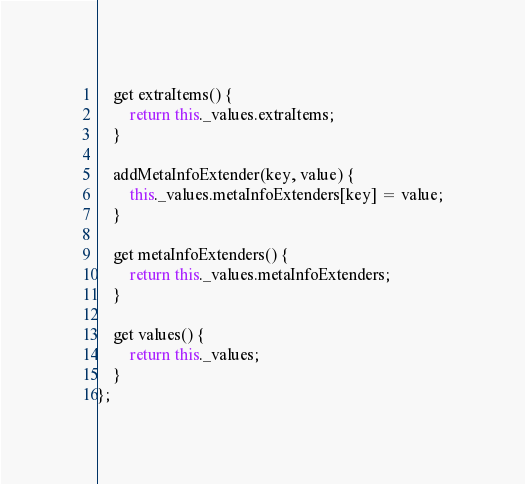<code> <loc_0><loc_0><loc_500><loc_500><_JavaScript_>
    get extraItems() {
        return this._values.extraItems;
    }

    addMetaInfoExtender(key, value) {
        this._values.metaInfoExtenders[key] = value;
    }

    get metaInfoExtenders() {
        return this._values.metaInfoExtenders;
    }

    get values() {
        return this._values;
    }
};
</code> 